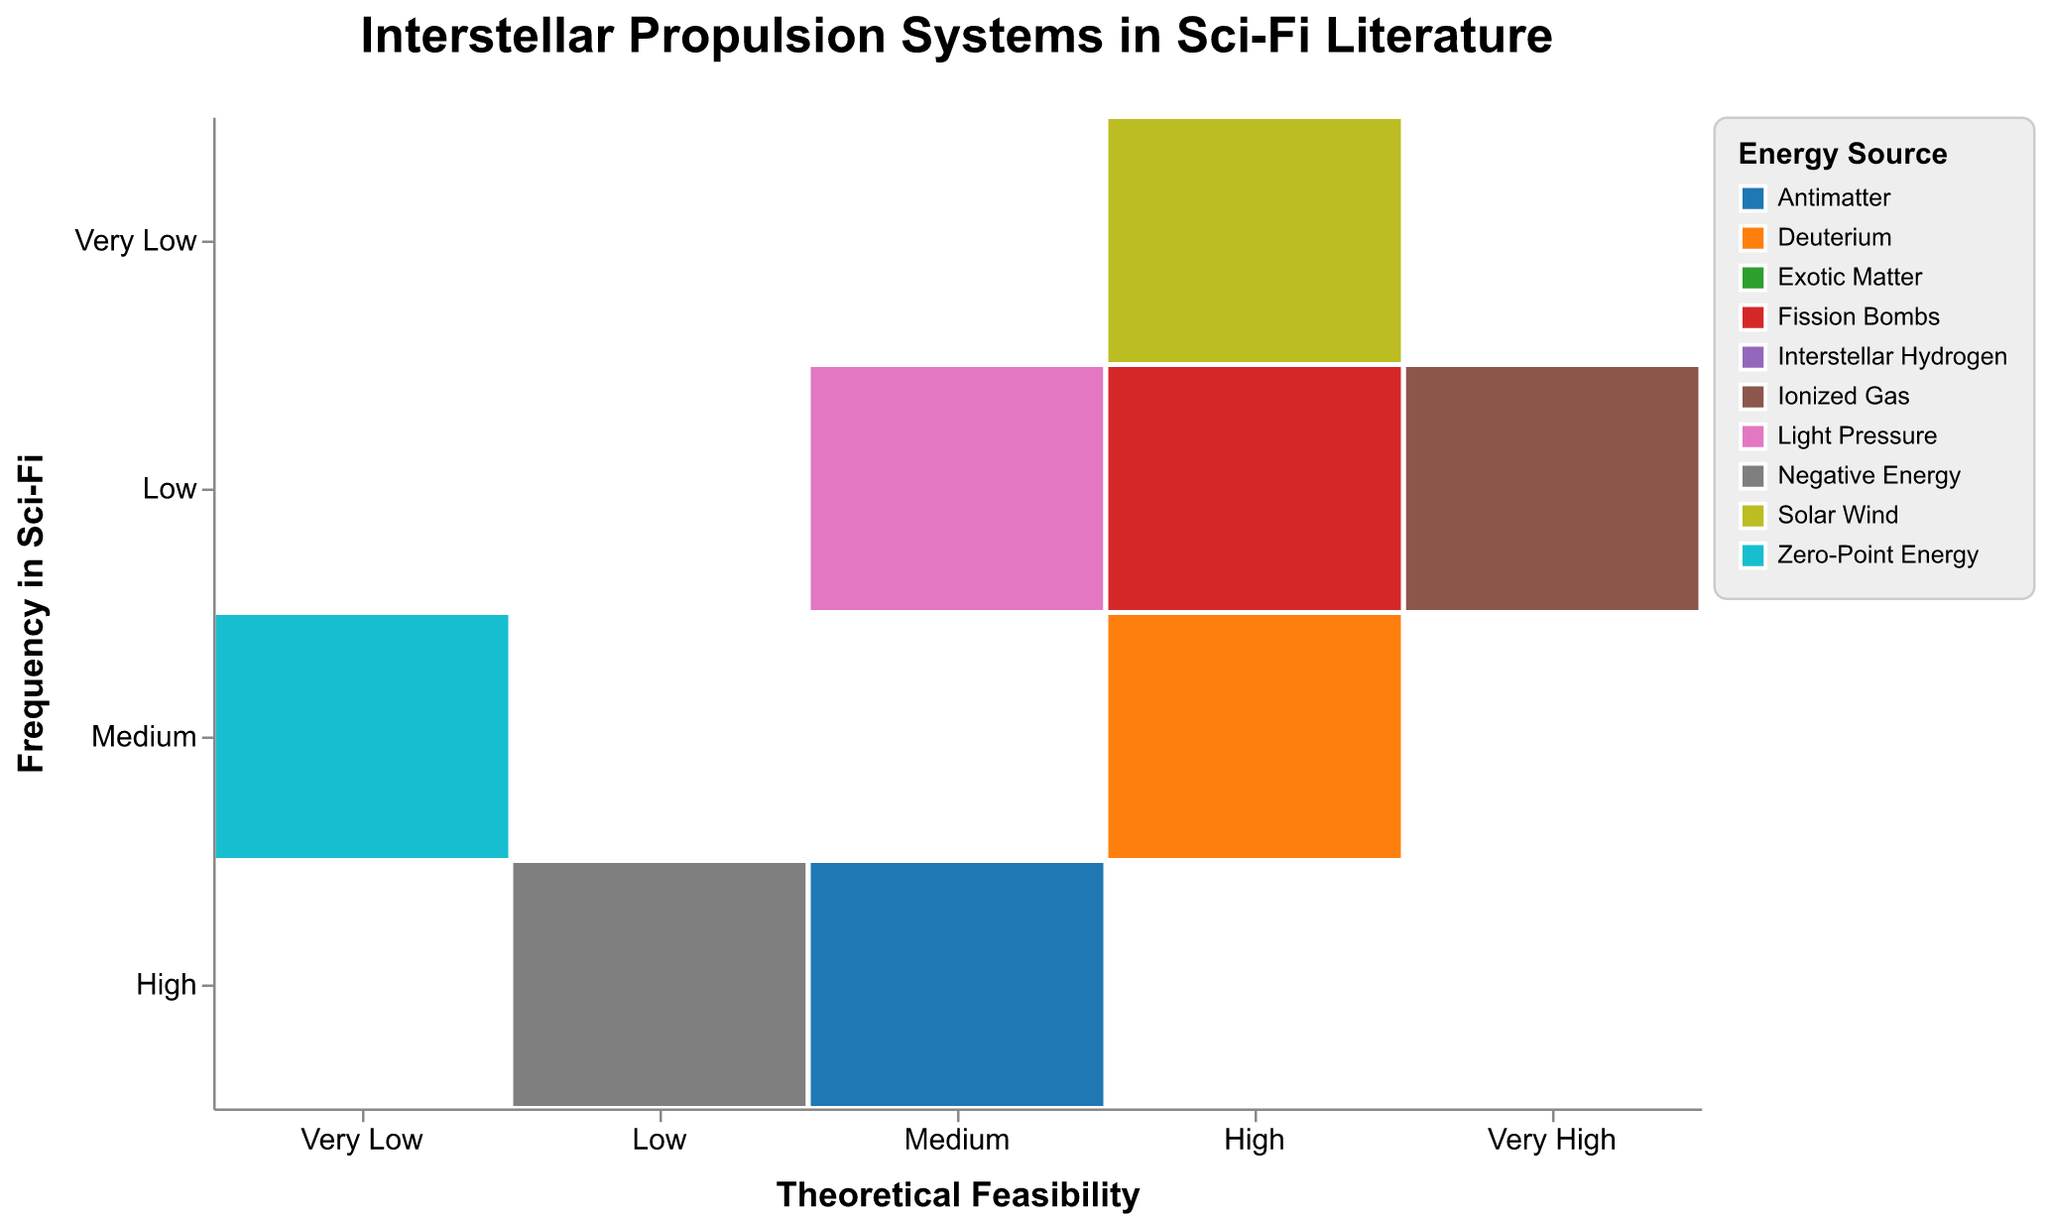How many propulsion systems have a "High" theoretical feasibility? By examining the x-axis for "High" theoretical feasibility, there are three marked rectangles corresponding to this category.
Answer: 3 Which energy source is used by the propulsion system with the highest theoretical feasibility? Look at the "Very High" category on the x-axis and identify the corresponding color and legend for "Ionized Gas." The Ion Engine uses this energy source.
Answer: Ionized Gas Which propulsion system is both very frequently mentioned in sci-fi literature and has a "Low" theoretical feasibility? Refer to the "Low" column on the x-axis and the "High" row on the y-axis; only the Warp Drive system, which uses Negative Energy, matches these criteria.
Answer: Warp Drive Compare the frequency in sci-fi for propulsion systems with "Medium" theoretical feasibility. Which one is the most common? Look at the "Medium" category on the x-axis and compare the rows. The Antimatter Engine in the "High" frequency row is most common.
Answer: Antimatter Engine What is the frequency in sci-fi of the propulsion system powered by Fission Bombs? Look for the color representing "Fission Bombs" in the legend and find the corresponding rectangle. It is in the "Low" category for frequency.
Answer: Low Which energy source appears in sci-fi literature with a "Very Low" theoretical feasibility the most? Analyze the "Very Low" column on the x-axis and compare the rows. "Exotic Matter" and "Zero-Point Energy" appear in the "Medium" row for frequency, which is the highest in this category.
Answer: Exotic Matter, Zero-Point Energy Which propulsion system with "High" theoretical feasibility is least frequent in sci-fi literature? Examine the "High" column x-axis and the corresponding rows on the y-axis. The Magnetic Sail in the "Very Low" frequency row is the least frequent.
Answer: Magnetic Sail Which propulsion systems are based on "Antimatter" and "Interstellar Hydrogen"? Which has a higher theoretical feasibility? Refer to the colors representing "Antimatter" and "Interstellar Hydrogen" and check their placements on the x-axis. "Antimatter Engine" is "Medium," while "Bussard Ramjet" is also "Medium." Both have the same feasibility.
Answer: Both are Medium Determine the number of propulsion systems with "Medium" theoretical feasibility and "Low" frequency in sci-fi. Look at the "Medium" column on the x-axis and the "Low" row on the y-axis. The corresponding rectangles are Bussard Ramjet and Photon Drive.
Answer: 2 Which energy sources are linked to propulsion systems with the highest overall frequency in sci-fi literature? Find the "High" frequency row on the y-axis and cross-reference it with the energy sources. The relevant energy sources are Negative Energy and Antimatter (Warp Drive and Antimatter Engine).
Answer: Negative Energy, Antimatter 